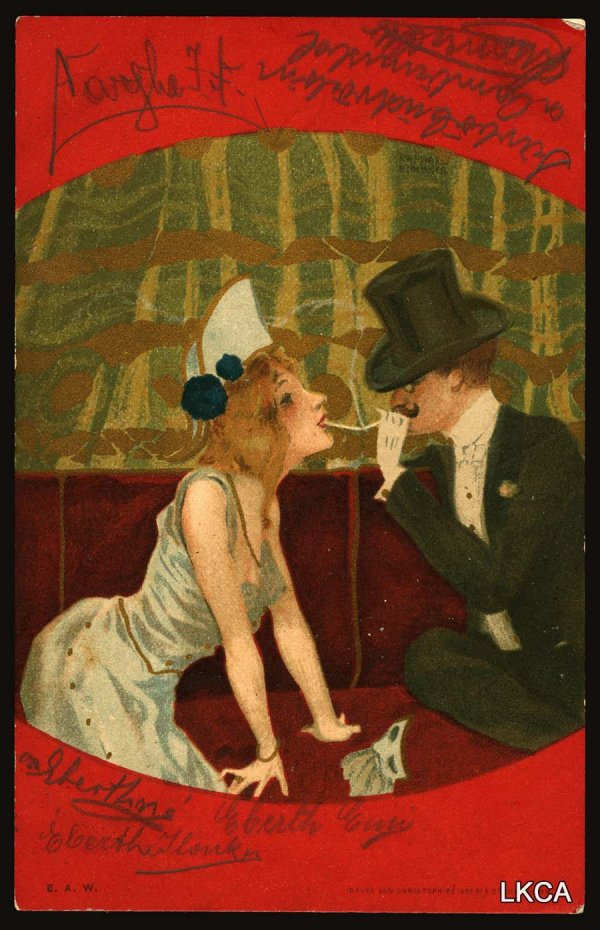If this scene were part of a movie, what genre would it be and why? This scene would be a perfect fit for a romantic drama film. The intimate setting, the artistically styled imagery, and the tender interaction between the man and woman all contribute to a story that revolves around deep emotions and relationships. The artistic sensibility of the image hints at a beautifully crafted narrative filled with passion, longing, and the complexities of love. 